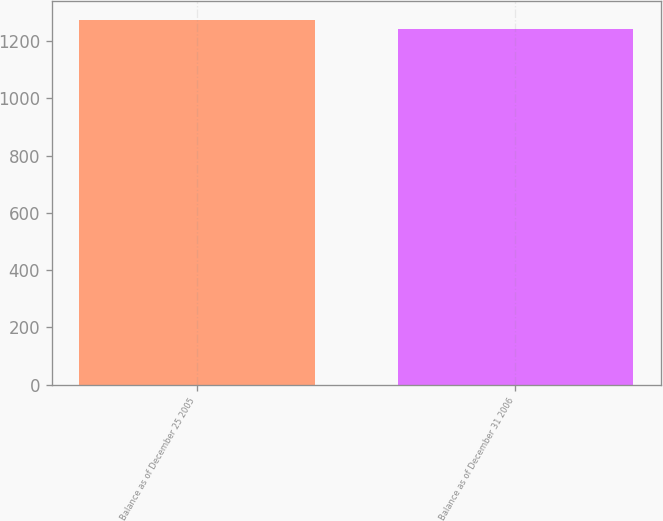Convert chart to OTSL. <chart><loc_0><loc_0><loc_500><loc_500><bar_chart><fcel>Balance as of December 25 2005<fcel>Balance as of December 31 2006<nl><fcel>1275<fcel>1244<nl></chart> 